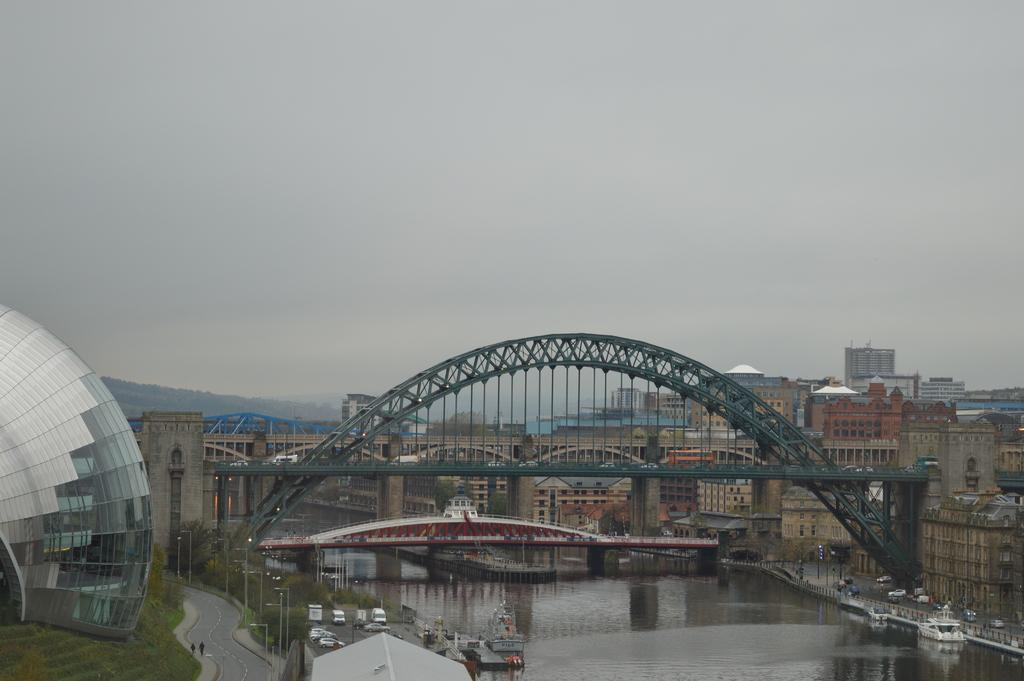What type of structures can be seen in the image? There are buildings in the image. What type of transportation infrastructure is present in the image? There are bridges in the image. What natural element is visible in the image? Water is visible in the image. What architectural features can be observed in the image? Architectural elements are present in the image. How would you describe the weather in the image? The sky is cloudy in the image. What type of vegetation is present in the image? There are trees and grass in the image. What type of transportation is visible in the image? There are roads and vehicles in the image. What type of activity is taking place in the image? People are present in the image. What type of watercraft can be seen in the image? Boats are visible in the image. Are there any other objects or features in the image? There are other objects in the image. What time is displayed on the clock in the image? There is no clock present in the image. What sound does the whistle make in the image? There is no whistle present in the image. 